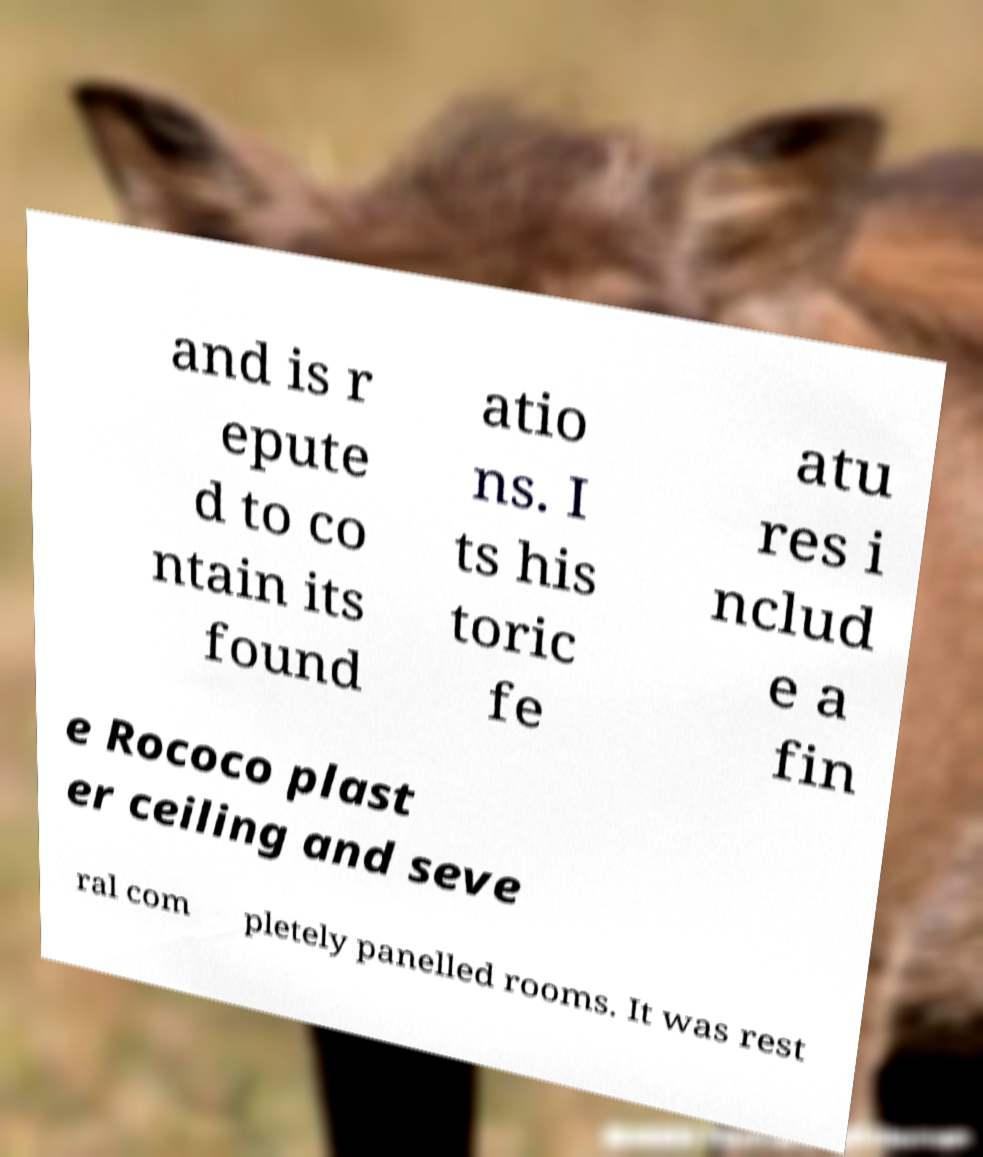There's text embedded in this image that I need extracted. Can you transcribe it verbatim? and is r epute d to co ntain its found atio ns. I ts his toric fe atu res i nclud e a fin e Rococo plast er ceiling and seve ral com pletely panelled rooms. It was rest 